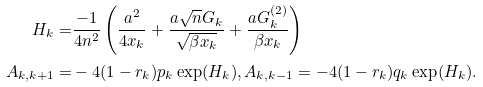<formula> <loc_0><loc_0><loc_500><loc_500>H _ { k } = & \frac { - 1 } { 4 n ^ { 2 } } \left ( \frac { a ^ { 2 } } { 4 x _ { k } } + \frac { a \sqrt { n } G _ { k } } { \sqrt { \beta x _ { k } } } + \frac { a G ^ { ( 2 ) } _ { k } } { \beta x _ { k } } \right ) \\ A _ { k , k + 1 } = & - 4 ( 1 - r _ { k } ) p _ { k } \exp ( H _ { k } ) , A _ { k , k - 1 } = - 4 ( 1 - r _ { k } ) q _ { k } \exp ( H _ { k } ) .</formula> 